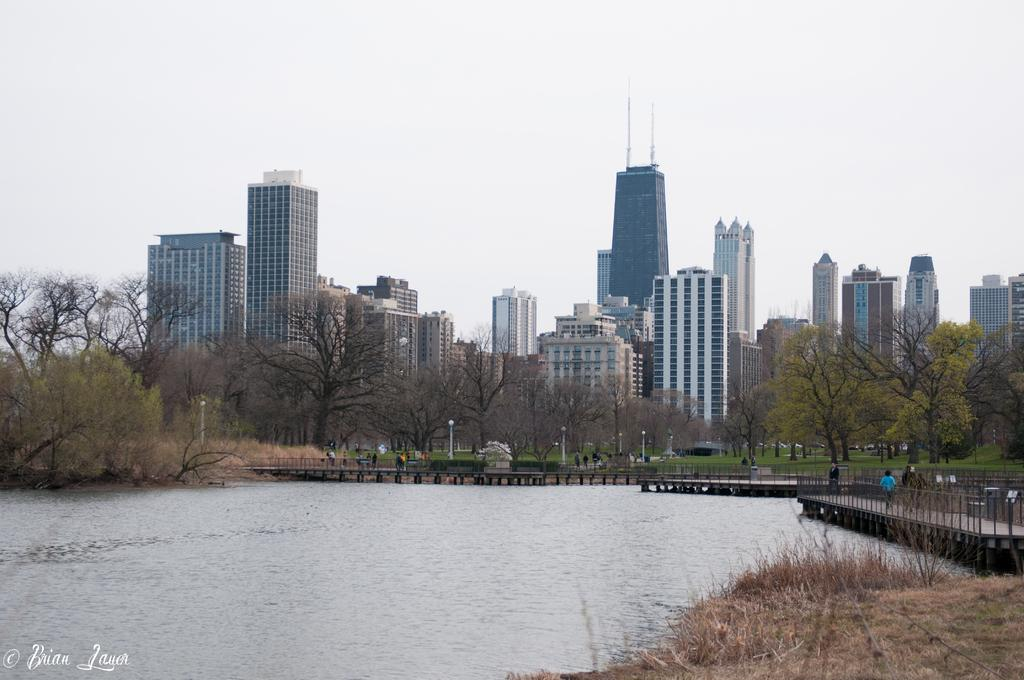What is the primary element visible in the image? There is water in the image. What type of natural vegetation can be seen in the image? There are trees in the image. What type of man-made structures are present in the image? There are big buildings in the image. What type of cable can be seen connecting the trees in the image? There is no cable connecting the trees in the image; only water, trees, and big buildings are present. 